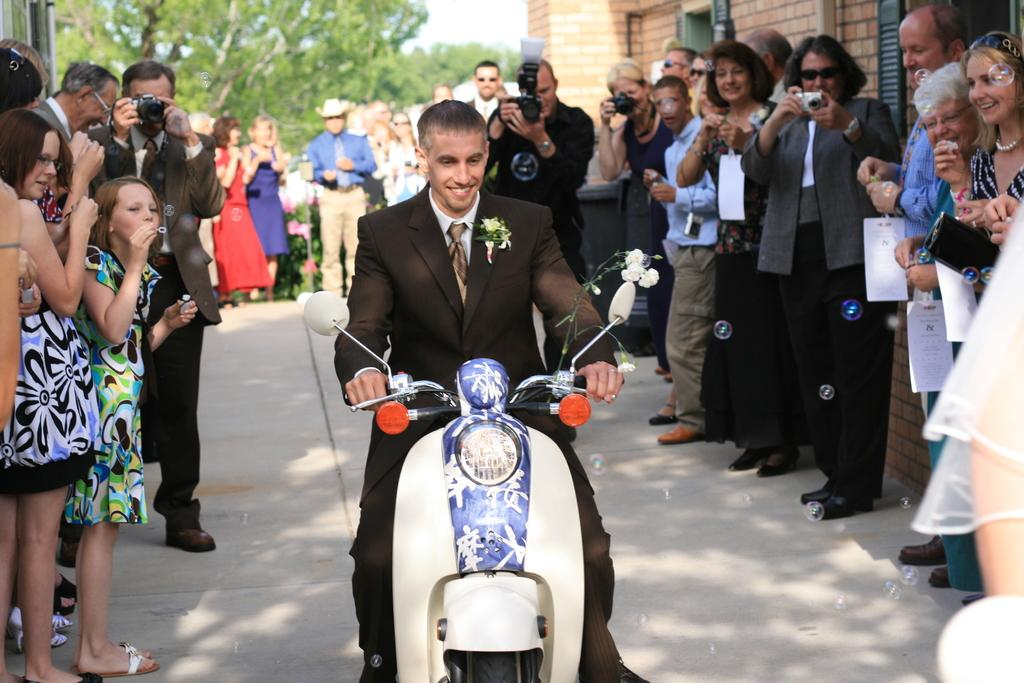What is the man in the image doing? The man is riding a bike in the image. What other people can be seen in the image? There are people (men and women) standing in the image. What object is used to capture images in the image? There is a camera in the image. What type of natural vegetation is present in the image? There are trees in the image. What type of structure is visible in the image? There is a building in the image. What type of doll is sitting on the road in the image? There is no doll present in the image, and there is no mention of a road in the provided facts. 